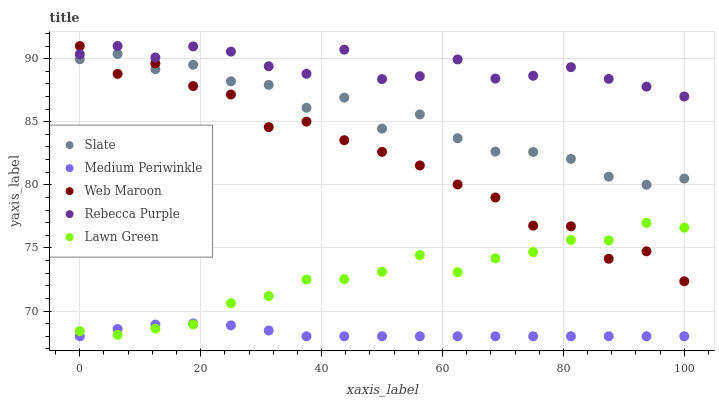Does Medium Periwinkle have the minimum area under the curve?
Answer yes or no. Yes. Does Rebecca Purple have the maximum area under the curve?
Answer yes or no. Yes. Does Slate have the minimum area under the curve?
Answer yes or no. No. Does Slate have the maximum area under the curve?
Answer yes or no. No. Is Medium Periwinkle the smoothest?
Answer yes or no. Yes. Is Web Maroon the roughest?
Answer yes or no. Yes. Is Slate the smoothest?
Answer yes or no. No. Is Slate the roughest?
Answer yes or no. No. Does Medium Periwinkle have the lowest value?
Answer yes or no. Yes. Does Slate have the lowest value?
Answer yes or no. No. Does Rebecca Purple have the highest value?
Answer yes or no. Yes. Does Slate have the highest value?
Answer yes or no. No. Is Medium Periwinkle less than Rebecca Purple?
Answer yes or no. Yes. Is Rebecca Purple greater than Lawn Green?
Answer yes or no. Yes. Does Slate intersect Web Maroon?
Answer yes or no. Yes. Is Slate less than Web Maroon?
Answer yes or no. No. Is Slate greater than Web Maroon?
Answer yes or no. No. Does Medium Periwinkle intersect Rebecca Purple?
Answer yes or no. No. 